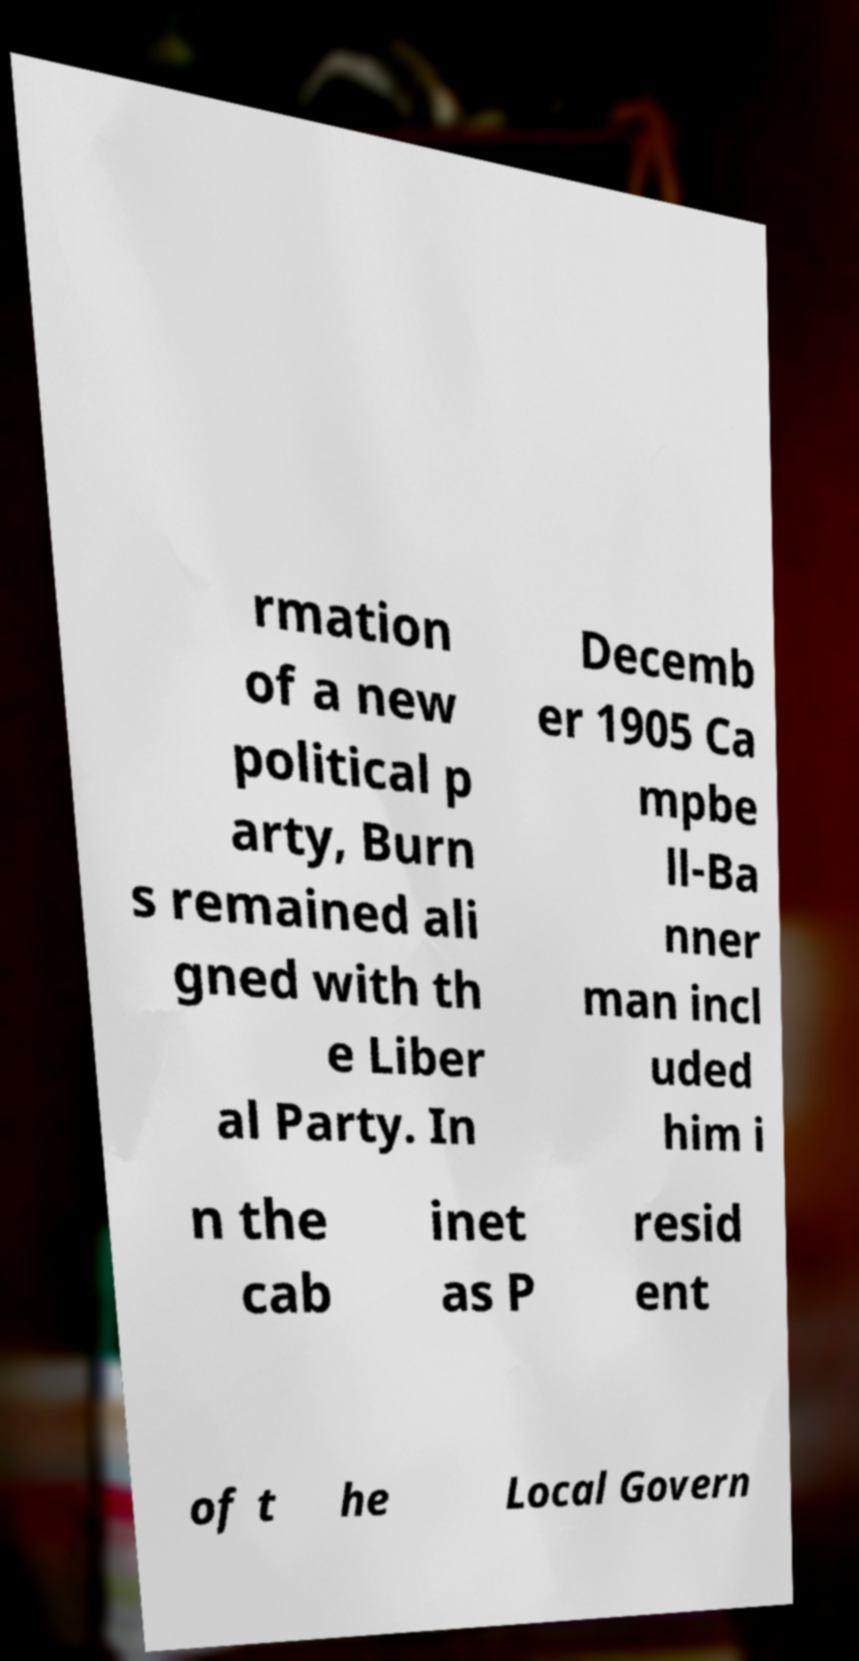Could you assist in decoding the text presented in this image and type it out clearly? rmation of a new political p arty, Burn s remained ali gned with th e Liber al Party. In Decemb er 1905 Ca mpbe ll-Ba nner man incl uded him i n the cab inet as P resid ent of t he Local Govern 